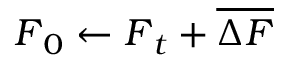Convert formula to latex. <formula><loc_0><loc_0><loc_500><loc_500>F _ { 0 } \gets F _ { t } + \overline { \Delta F }</formula> 